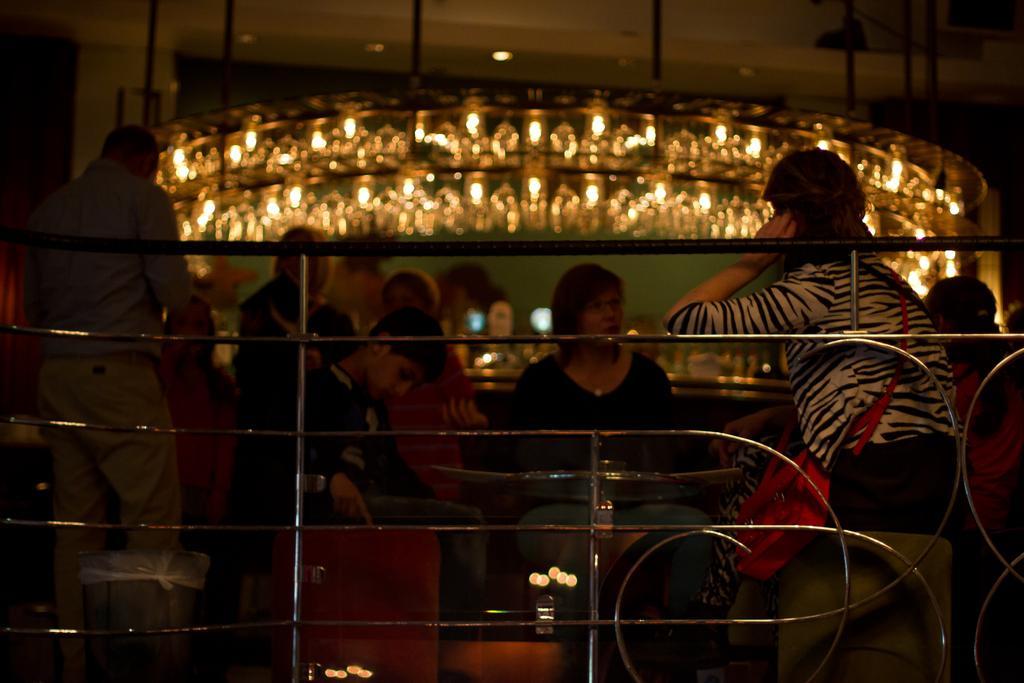Describe this image in one or two sentences. In the picture we can see a railing and behind it we can see three people are sitting on the chairs near the table and they are talking and behind them also we can see some people are standing and beside them we can see a desk with some things placed on it and in the background we can see full of lights to the wall. 